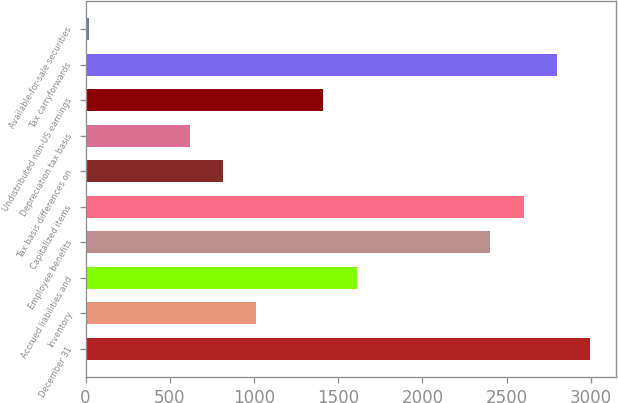<chart> <loc_0><loc_0><loc_500><loc_500><bar_chart><fcel>December 31<fcel>Inventory<fcel>Accrued liabilities and<fcel>Employee benefits<fcel>Capitalized items<fcel>Tax basis differences on<fcel>Depreciation tax basis<fcel>Undistributed non-US earnings<fcel>Tax carryforwards<fcel>Available-for-sale securities<nl><fcel>2997.5<fcel>1014.5<fcel>1609.4<fcel>2402.6<fcel>2600.9<fcel>816.2<fcel>617.9<fcel>1411.1<fcel>2799.2<fcel>23<nl></chart> 